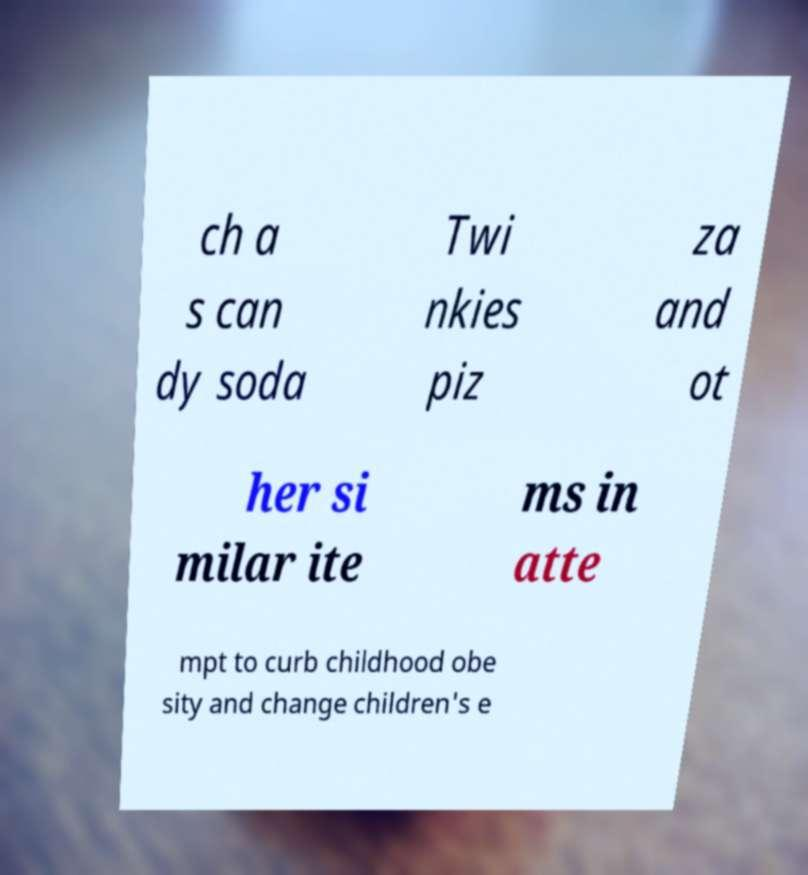What messages or text are displayed in this image? I need them in a readable, typed format. ch a s can dy soda Twi nkies piz za and ot her si milar ite ms in atte mpt to curb childhood obe sity and change children's e 